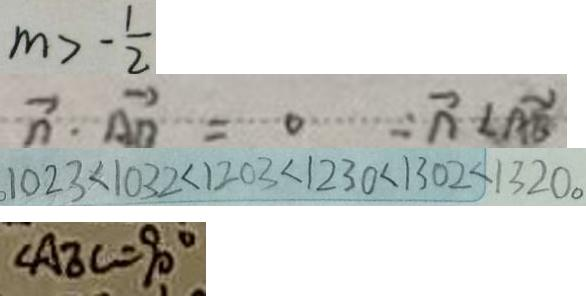<formula> <loc_0><loc_0><loc_500><loc_500>m > - \frac { 1 } { 2 } 
 \overrightarrow { n } \cdot \overrightarrow { A B } = 0 \cdots \overrightarrow { n } < \overrightarrow { A B } 
 1 0 2 3 < 1 0 3 2 < 1 2 0 3 < 1 2 3 0 < 1 3 0 2 < 1 3 2 0 。 
 \Delta A E C = 9 0 ^ { \circ }</formula> 